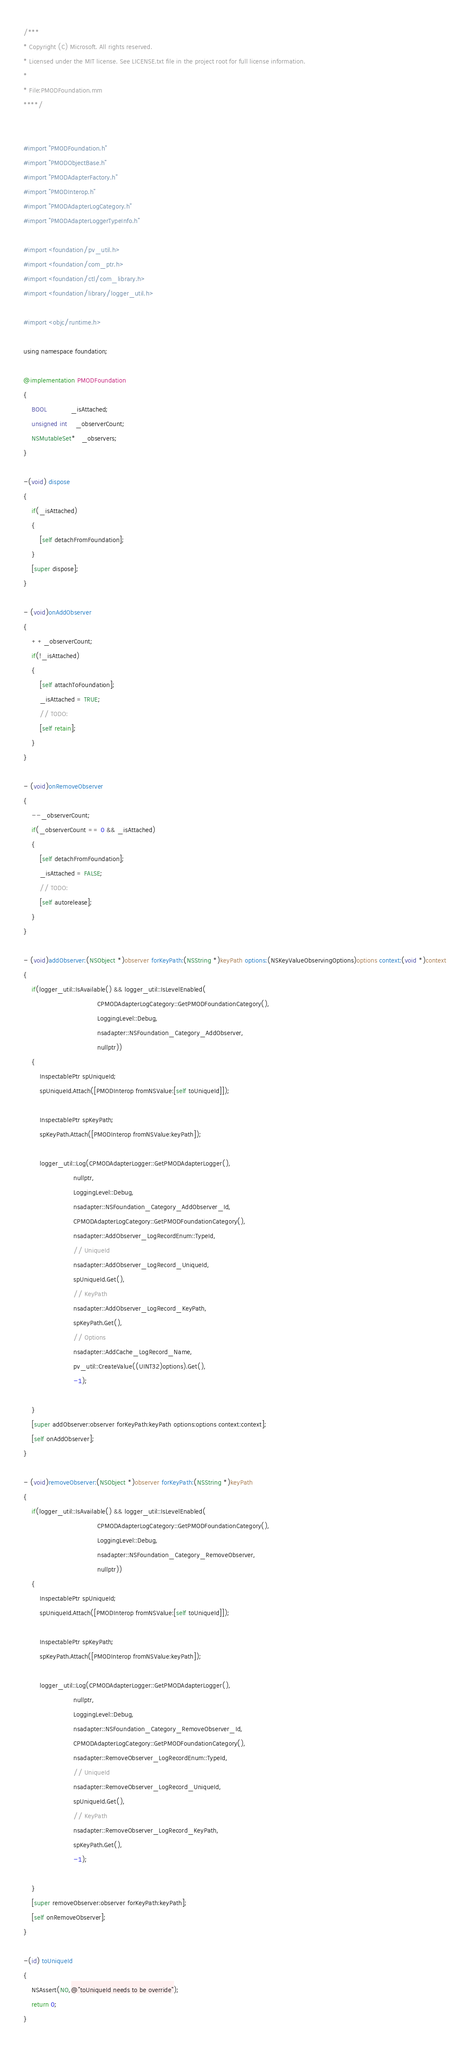Convert code to text. <code><loc_0><loc_0><loc_500><loc_500><_ObjectiveC_>/***
* Copyright (C) Microsoft. All rights reserved.
* Licensed under the MIT license. See LICENSE.txt file in the project root for full license information.
*
* File:PMODFoundation.mm
****/


#import "PMODFoundation.h"
#import "PMODObjectBase.h"
#import "PMODAdapterFactory.h"
#import "PMODInterop.h"
#import "PMODAdapterLogCategory.h"
#import "PMODAdapterLoggerTypeInfo.h"

#import <foundation/pv_util.h>
#import <foundation/com_ptr.h>
#import <foundation/ctl/com_library.h>
#import <foundation/library/logger_util.h>

#import <objc/runtime.h>

using namespace foundation;

@implementation PMODFoundation
{
    BOOL			_isAttached;
    unsigned int	_observerCount;
    NSMutableSet*   _observers;
}

-(void) dispose
{
	if(_isAttached)
	{
		[self detachFromFoundation];
	}
    [super dispose];
}

- (void)onAddObserver
{
	++_observerCount;
	if(!_isAttached)
	{
		[self attachToFoundation];
		_isAttached = TRUE;
		// TODO:
		[self retain];
	}    
}

- (void)onRemoveObserver
{
	--_observerCount;
	if(_observerCount == 0 && _isAttached)
	{
		[self detachFromFoundation];
		_isAttached = FALSE;
		// TODO:
		[self autorelease];
	}
}

- (void)addObserver:(NSObject *)observer forKeyPath:(NSString *)keyPath options:(NSKeyValueObservingOptions)options context:(void *)context
{
    if(logger_util::IsAvailable() && logger_util::IsLevelEnabled(
                                     CPMODAdapterLogCategory::GetPMODFoundationCategory(),
                                     LoggingLevel::Debug,
                                     nsadapter::NSFoundation_Category_AddObserver,
                                     nullptr))
    {
        InspectablePtr spUniqueId;
        spUniqueId.Attach([PMODInterop fromNSValue:[self toUniqueId]]);
        
        InspectablePtr spKeyPath;
        spKeyPath.Attach([PMODInterop fromNSValue:keyPath]);
 
        logger_util::Log(CPMODAdapterLogger::GetPMODAdapterLogger(),
                         nullptr,
                         LoggingLevel::Debug,
                         nsadapter::NSFoundation_Category_AddObserver_Id,
                         CPMODAdapterLogCategory::GetPMODFoundationCategory(),
                         nsadapter::AddObserver_LogRecordEnum::TypeId,
                         // UniqueId
                         nsadapter::AddObserver_LogRecord_UniqueId,
                         spUniqueId.Get(),
                         // KeyPath
                         nsadapter::AddObserver_LogRecord_KeyPath,
                         spKeyPath.Get(),
                         // Options
                         nsadapter::AddCache_LogRecord_Name,
                         pv_util::CreateValue((UINT32)options).Get(),
                         -1);

    }
	[super addObserver:observer forKeyPath:keyPath options:options context:context];
    [self onAddObserver];
}

- (void)removeObserver:(NSObject *)observer forKeyPath:(NSString *)keyPath
{
    if(logger_util::IsAvailable() && logger_util::IsLevelEnabled(
                                     CPMODAdapterLogCategory::GetPMODFoundationCategory(),
                                     LoggingLevel::Debug,
                                     nsadapter::NSFoundation_Category_RemoveObserver,
                                     nullptr))
    {
        InspectablePtr spUniqueId;
        spUniqueId.Attach([PMODInterop fromNSValue:[self toUniqueId]]);
        
        InspectablePtr spKeyPath;
        spKeyPath.Attach([PMODInterop fromNSValue:keyPath]);
        
        logger_util::Log(CPMODAdapterLogger::GetPMODAdapterLogger(),
                         nullptr,
                         LoggingLevel::Debug,
                         nsadapter::NSFoundation_Category_RemoveObserver_Id,
                         CPMODAdapterLogCategory::GetPMODFoundationCategory(),
                         nsadapter::RemoveObserver_LogRecordEnum::TypeId,
                         // UniqueId
                         nsadapter::RemoveObserver_LogRecord_UniqueId,
                         spUniqueId.Get(),
                         // KeyPath
                         nsadapter::RemoveObserver_LogRecord_KeyPath,
                         spKeyPath.Get(),
                         -1);
        
    }
	[super removeObserver:observer forKeyPath:keyPath];
    [self onRemoveObserver];
}

-(id) toUniqueId
{
	NSAssert(NO,@"toUniqueId needs to be override");
    return 0;
}</code> 